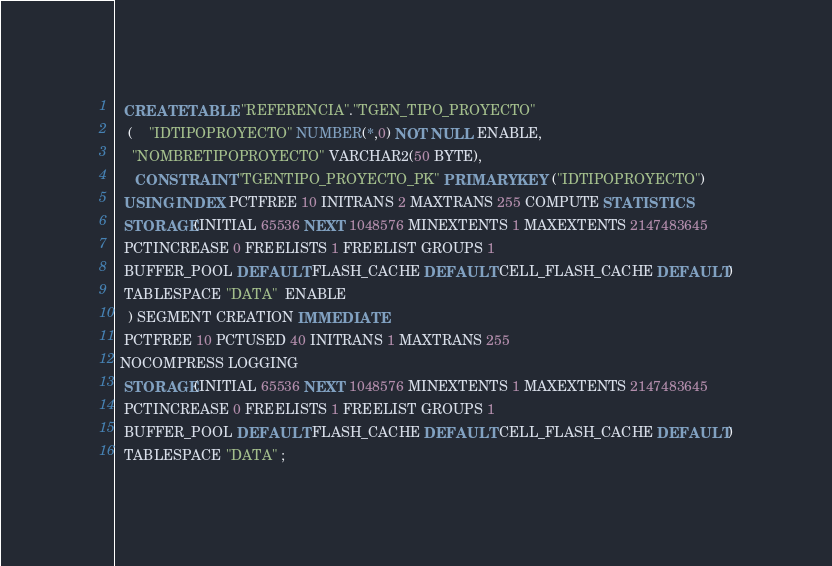Convert code to text. <code><loc_0><loc_0><loc_500><loc_500><_SQL_>
  CREATE TABLE "REFERENCIA"."TGEN_TIPO_PROYECTO" 
   (	"IDTIPOPROYECTO" NUMBER(*,0) NOT NULL ENABLE, 
	"NOMBRETIPOPROYECTO" VARCHAR2(50 BYTE), 
	 CONSTRAINT "TGENTIPO_PROYECTO_PK" PRIMARY KEY ("IDTIPOPROYECTO")
  USING INDEX PCTFREE 10 INITRANS 2 MAXTRANS 255 COMPUTE STATISTICS 
  STORAGE(INITIAL 65536 NEXT 1048576 MINEXTENTS 1 MAXEXTENTS 2147483645
  PCTINCREASE 0 FREELISTS 1 FREELIST GROUPS 1
  BUFFER_POOL DEFAULT FLASH_CACHE DEFAULT CELL_FLASH_CACHE DEFAULT)
  TABLESPACE "DATA"  ENABLE
   ) SEGMENT CREATION IMMEDIATE 
  PCTFREE 10 PCTUSED 40 INITRANS 1 MAXTRANS 255 
 NOCOMPRESS LOGGING
  STORAGE(INITIAL 65536 NEXT 1048576 MINEXTENTS 1 MAXEXTENTS 2147483645
  PCTINCREASE 0 FREELISTS 1 FREELIST GROUPS 1
  BUFFER_POOL DEFAULT FLASH_CACHE DEFAULT CELL_FLASH_CACHE DEFAULT)
  TABLESPACE "DATA" ;
</code> 